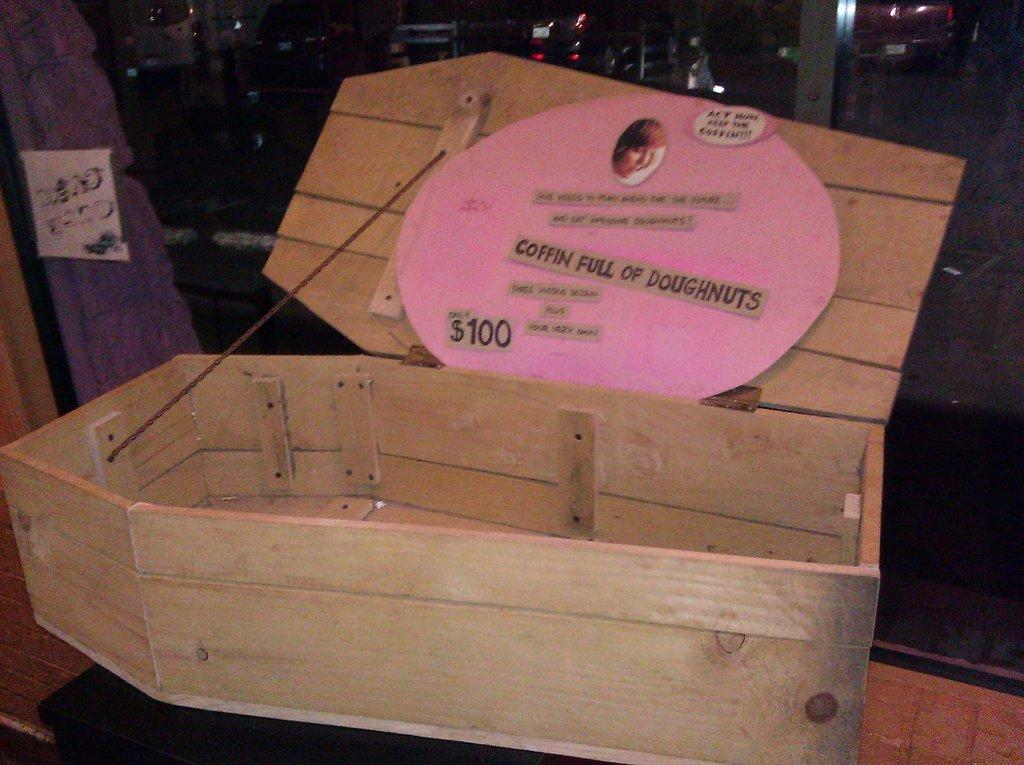<image>
Create a compact narrative representing the image presented. A coffin box with a pink sign saying coffin full of doughnuts. 